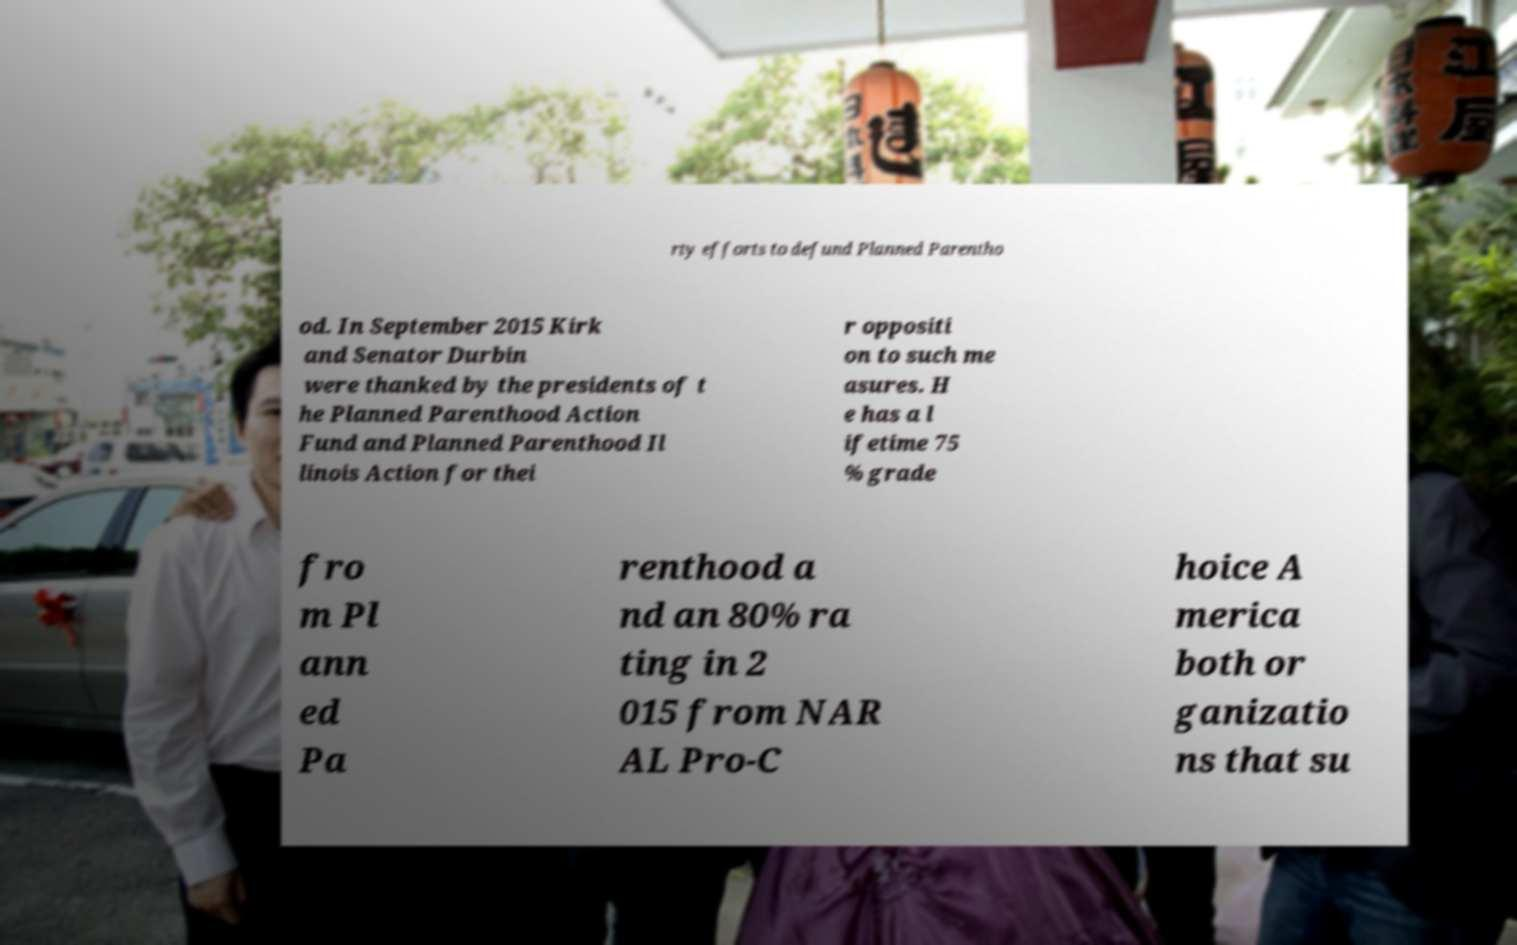Can you read and provide the text displayed in the image?This photo seems to have some interesting text. Can you extract and type it out for me? rty efforts to defund Planned Parentho od. In September 2015 Kirk and Senator Durbin were thanked by the presidents of t he Planned Parenthood Action Fund and Planned Parenthood Il linois Action for thei r oppositi on to such me asures. H e has a l ifetime 75 % grade fro m Pl ann ed Pa renthood a nd an 80% ra ting in 2 015 from NAR AL Pro-C hoice A merica both or ganizatio ns that su 